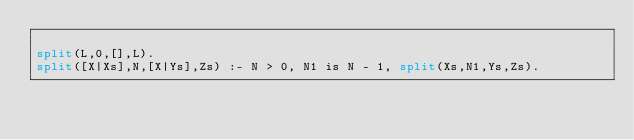Convert code to text. <code><loc_0><loc_0><loc_500><loc_500><_Perl_>
split(L,0,[],L).
split([X|Xs],N,[X|Ys],Zs) :- N > 0, N1 is N - 1, split(Xs,N1,Ys,Zs).

</code> 